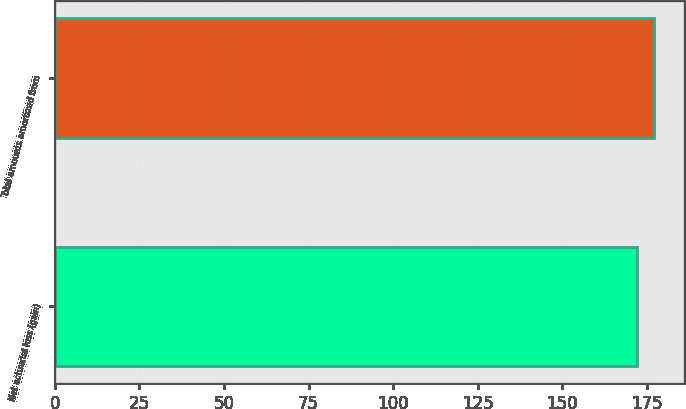Convert chart to OTSL. <chart><loc_0><loc_0><loc_500><loc_500><bar_chart><fcel>Net actuarial loss (gain)<fcel>Total amounts amortized from<nl><fcel>172<fcel>177<nl></chart> 